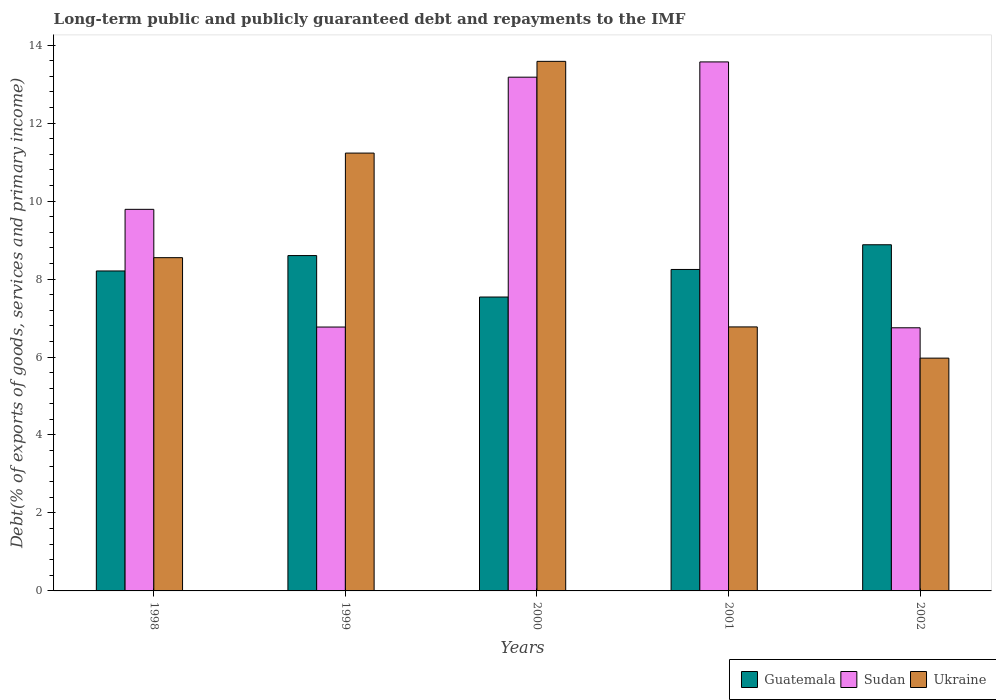Are the number of bars per tick equal to the number of legend labels?
Your answer should be compact. Yes. Are the number of bars on each tick of the X-axis equal?
Keep it short and to the point. Yes. How many bars are there on the 1st tick from the right?
Give a very brief answer. 3. What is the debt and repayments in Ukraine in 1999?
Keep it short and to the point. 11.23. Across all years, what is the maximum debt and repayments in Ukraine?
Your response must be concise. 13.59. Across all years, what is the minimum debt and repayments in Ukraine?
Your response must be concise. 5.97. In which year was the debt and repayments in Guatemala maximum?
Offer a terse response. 2002. What is the total debt and repayments in Guatemala in the graph?
Provide a succinct answer. 41.48. What is the difference between the debt and repayments in Sudan in 1999 and that in 2000?
Keep it short and to the point. -6.41. What is the difference between the debt and repayments in Ukraine in 2000 and the debt and repayments in Sudan in 2001?
Your response must be concise. 0.01. What is the average debt and repayments in Sudan per year?
Your response must be concise. 10.01. In the year 2002, what is the difference between the debt and repayments in Sudan and debt and repayments in Guatemala?
Your answer should be very brief. -2.13. What is the ratio of the debt and repayments in Sudan in 1998 to that in 2002?
Make the answer very short. 1.45. Is the difference between the debt and repayments in Sudan in 1999 and 2002 greater than the difference between the debt and repayments in Guatemala in 1999 and 2002?
Your response must be concise. Yes. What is the difference between the highest and the second highest debt and repayments in Guatemala?
Offer a very short reply. 0.28. What is the difference between the highest and the lowest debt and repayments in Sudan?
Keep it short and to the point. 6.82. Is the sum of the debt and repayments in Guatemala in 1999 and 2002 greater than the maximum debt and repayments in Sudan across all years?
Your answer should be very brief. Yes. What does the 1st bar from the left in 2001 represents?
Your answer should be very brief. Guatemala. What does the 2nd bar from the right in 2000 represents?
Offer a terse response. Sudan. How many bars are there?
Make the answer very short. 15. How many years are there in the graph?
Your answer should be very brief. 5. Does the graph contain any zero values?
Make the answer very short. No. What is the title of the graph?
Ensure brevity in your answer.  Long-term public and publicly guaranteed debt and repayments to the IMF. What is the label or title of the Y-axis?
Ensure brevity in your answer.  Debt(% of exports of goods, services and primary income). What is the Debt(% of exports of goods, services and primary income) in Guatemala in 1998?
Your response must be concise. 8.21. What is the Debt(% of exports of goods, services and primary income) of Sudan in 1998?
Provide a short and direct response. 9.79. What is the Debt(% of exports of goods, services and primary income) in Ukraine in 1998?
Your response must be concise. 8.55. What is the Debt(% of exports of goods, services and primary income) of Guatemala in 1999?
Your response must be concise. 8.6. What is the Debt(% of exports of goods, services and primary income) in Sudan in 1999?
Make the answer very short. 6.77. What is the Debt(% of exports of goods, services and primary income) of Ukraine in 1999?
Make the answer very short. 11.23. What is the Debt(% of exports of goods, services and primary income) of Guatemala in 2000?
Your response must be concise. 7.54. What is the Debt(% of exports of goods, services and primary income) of Sudan in 2000?
Ensure brevity in your answer.  13.18. What is the Debt(% of exports of goods, services and primary income) of Ukraine in 2000?
Give a very brief answer. 13.59. What is the Debt(% of exports of goods, services and primary income) of Guatemala in 2001?
Ensure brevity in your answer.  8.25. What is the Debt(% of exports of goods, services and primary income) of Sudan in 2001?
Provide a succinct answer. 13.57. What is the Debt(% of exports of goods, services and primary income) of Ukraine in 2001?
Your response must be concise. 6.77. What is the Debt(% of exports of goods, services and primary income) in Guatemala in 2002?
Offer a terse response. 8.88. What is the Debt(% of exports of goods, services and primary income) of Sudan in 2002?
Ensure brevity in your answer.  6.75. What is the Debt(% of exports of goods, services and primary income) in Ukraine in 2002?
Your answer should be very brief. 5.97. Across all years, what is the maximum Debt(% of exports of goods, services and primary income) in Guatemala?
Provide a short and direct response. 8.88. Across all years, what is the maximum Debt(% of exports of goods, services and primary income) in Sudan?
Make the answer very short. 13.57. Across all years, what is the maximum Debt(% of exports of goods, services and primary income) in Ukraine?
Give a very brief answer. 13.59. Across all years, what is the minimum Debt(% of exports of goods, services and primary income) in Guatemala?
Offer a very short reply. 7.54. Across all years, what is the minimum Debt(% of exports of goods, services and primary income) in Sudan?
Offer a terse response. 6.75. Across all years, what is the minimum Debt(% of exports of goods, services and primary income) in Ukraine?
Offer a terse response. 5.97. What is the total Debt(% of exports of goods, services and primary income) in Guatemala in the graph?
Your answer should be compact. 41.48. What is the total Debt(% of exports of goods, services and primary income) of Sudan in the graph?
Ensure brevity in your answer.  50.06. What is the total Debt(% of exports of goods, services and primary income) of Ukraine in the graph?
Make the answer very short. 46.11. What is the difference between the Debt(% of exports of goods, services and primary income) in Guatemala in 1998 and that in 1999?
Offer a very short reply. -0.39. What is the difference between the Debt(% of exports of goods, services and primary income) of Sudan in 1998 and that in 1999?
Your answer should be very brief. 3.02. What is the difference between the Debt(% of exports of goods, services and primary income) of Ukraine in 1998 and that in 1999?
Offer a terse response. -2.68. What is the difference between the Debt(% of exports of goods, services and primary income) of Guatemala in 1998 and that in 2000?
Ensure brevity in your answer.  0.67. What is the difference between the Debt(% of exports of goods, services and primary income) in Sudan in 1998 and that in 2000?
Your answer should be very brief. -3.39. What is the difference between the Debt(% of exports of goods, services and primary income) of Ukraine in 1998 and that in 2000?
Ensure brevity in your answer.  -5.04. What is the difference between the Debt(% of exports of goods, services and primary income) of Guatemala in 1998 and that in 2001?
Your answer should be compact. -0.04. What is the difference between the Debt(% of exports of goods, services and primary income) in Sudan in 1998 and that in 2001?
Make the answer very short. -3.78. What is the difference between the Debt(% of exports of goods, services and primary income) in Ukraine in 1998 and that in 2001?
Keep it short and to the point. 1.78. What is the difference between the Debt(% of exports of goods, services and primary income) in Guatemala in 1998 and that in 2002?
Give a very brief answer. -0.67. What is the difference between the Debt(% of exports of goods, services and primary income) of Sudan in 1998 and that in 2002?
Ensure brevity in your answer.  3.04. What is the difference between the Debt(% of exports of goods, services and primary income) in Ukraine in 1998 and that in 2002?
Provide a short and direct response. 2.58. What is the difference between the Debt(% of exports of goods, services and primary income) in Guatemala in 1999 and that in 2000?
Provide a succinct answer. 1.06. What is the difference between the Debt(% of exports of goods, services and primary income) in Sudan in 1999 and that in 2000?
Keep it short and to the point. -6.41. What is the difference between the Debt(% of exports of goods, services and primary income) of Ukraine in 1999 and that in 2000?
Ensure brevity in your answer.  -2.35. What is the difference between the Debt(% of exports of goods, services and primary income) in Guatemala in 1999 and that in 2001?
Your response must be concise. 0.36. What is the difference between the Debt(% of exports of goods, services and primary income) in Sudan in 1999 and that in 2001?
Give a very brief answer. -6.8. What is the difference between the Debt(% of exports of goods, services and primary income) in Ukraine in 1999 and that in 2001?
Your answer should be very brief. 4.46. What is the difference between the Debt(% of exports of goods, services and primary income) of Guatemala in 1999 and that in 2002?
Provide a short and direct response. -0.28. What is the difference between the Debt(% of exports of goods, services and primary income) of Sudan in 1999 and that in 2002?
Offer a terse response. 0.02. What is the difference between the Debt(% of exports of goods, services and primary income) of Ukraine in 1999 and that in 2002?
Provide a short and direct response. 5.26. What is the difference between the Debt(% of exports of goods, services and primary income) in Guatemala in 2000 and that in 2001?
Keep it short and to the point. -0.71. What is the difference between the Debt(% of exports of goods, services and primary income) of Sudan in 2000 and that in 2001?
Make the answer very short. -0.39. What is the difference between the Debt(% of exports of goods, services and primary income) of Ukraine in 2000 and that in 2001?
Your response must be concise. 6.81. What is the difference between the Debt(% of exports of goods, services and primary income) of Guatemala in 2000 and that in 2002?
Provide a succinct answer. -1.34. What is the difference between the Debt(% of exports of goods, services and primary income) in Sudan in 2000 and that in 2002?
Keep it short and to the point. 6.43. What is the difference between the Debt(% of exports of goods, services and primary income) of Ukraine in 2000 and that in 2002?
Ensure brevity in your answer.  7.61. What is the difference between the Debt(% of exports of goods, services and primary income) in Guatemala in 2001 and that in 2002?
Offer a terse response. -0.63. What is the difference between the Debt(% of exports of goods, services and primary income) of Sudan in 2001 and that in 2002?
Provide a succinct answer. 6.82. What is the difference between the Debt(% of exports of goods, services and primary income) in Ukraine in 2001 and that in 2002?
Provide a short and direct response. 0.8. What is the difference between the Debt(% of exports of goods, services and primary income) of Guatemala in 1998 and the Debt(% of exports of goods, services and primary income) of Sudan in 1999?
Your answer should be very brief. 1.44. What is the difference between the Debt(% of exports of goods, services and primary income) of Guatemala in 1998 and the Debt(% of exports of goods, services and primary income) of Ukraine in 1999?
Offer a terse response. -3.02. What is the difference between the Debt(% of exports of goods, services and primary income) of Sudan in 1998 and the Debt(% of exports of goods, services and primary income) of Ukraine in 1999?
Offer a very short reply. -1.44. What is the difference between the Debt(% of exports of goods, services and primary income) of Guatemala in 1998 and the Debt(% of exports of goods, services and primary income) of Sudan in 2000?
Your answer should be very brief. -4.97. What is the difference between the Debt(% of exports of goods, services and primary income) in Guatemala in 1998 and the Debt(% of exports of goods, services and primary income) in Ukraine in 2000?
Your answer should be compact. -5.38. What is the difference between the Debt(% of exports of goods, services and primary income) in Sudan in 1998 and the Debt(% of exports of goods, services and primary income) in Ukraine in 2000?
Offer a terse response. -3.8. What is the difference between the Debt(% of exports of goods, services and primary income) in Guatemala in 1998 and the Debt(% of exports of goods, services and primary income) in Sudan in 2001?
Offer a terse response. -5.36. What is the difference between the Debt(% of exports of goods, services and primary income) of Guatemala in 1998 and the Debt(% of exports of goods, services and primary income) of Ukraine in 2001?
Give a very brief answer. 1.44. What is the difference between the Debt(% of exports of goods, services and primary income) in Sudan in 1998 and the Debt(% of exports of goods, services and primary income) in Ukraine in 2001?
Give a very brief answer. 3.02. What is the difference between the Debt(% of exports of goods, services and primary income) in Guatemala in 1998 and the Debt(% of exports of goods, services and primary income) in Sudan in 2002?
Provide a succinct answer. 1.46. What is the difference between the Debt(% of exports of goods, services and primary income) in Guatemala in 1998 and the Debt(% of exports of goods, services and primary income) in Ukraine in 2002?
Your answer should be very brief. 2.24. What is the difference between the Debt(% of exports of goods, services and primary income) of Sudan in 1998 and the Debt(% of exports of goods, services and primary income) of Ukraine in 2002?
Provide a short and direct response. 3.82. What is the difference between the Debt(% of exports of goods, services and primary income) in Guatemala in 1999 and the Debt(% of exports of goods, services and primary income) in Sudan in 2000?
Offer a terse response. -4.58. What is the difference between the Debt(% of exports of goods, services and primary income) in Guatemala in 1999 and the Debt(% of exports of goods, services and primary income) in Ukraine in 2000?
Make the answer very short. -4.98. What is the difference between the Debt(% of exports of goods, services and primary income) of Sudan in 1999 and the Debt(% of exports of goods, services and primary income) of Ukraine in 2000?
Provide a succinct answer. -6.82. What is the difference between the Debt(% of exports of goods, services and primary income) of Guatemala in 1999 and the Debt(% of exports of goods, services and primary income) of Sudan in 2001?
Your answer should be very brief. -4.97. What is the difference between the Debt(% of exports of goods, services and primary income) in Guatemala in 1999 and the Debt(% of exports of goods, services and primary income) in Ukraine in 2001?
Your response must be concise. 1.83. What is the difference between the Debt(% of exports of goods, services and primary income) of Sudan in 1999 and the Debt(% of exports of goods, services and primary income) of Ukraine in 2001?
Your answer should be very brief. -0. What is the difference between the Debt(% of exports of goods, services and primary income) in Guatemala in 1999 and the Debt(% of exports of goods, services and primary income) in Sudan in 2002?
Ensure brevity in your answer.  1.85. What is the difference between the Debt(% of exports of goods, services and primary income) in Guatemala in 1999 and the Debt(% of exports of goods, services and primary income) in Ukraine in 2002?
Keep it short and to the point. 2.63. What is the difference between the Debt(% of exports of goods, services and primary income) in Sudan in 1999 and the Debt(% of exports of goods, services and primary income) in Ukraine in 2002?
Provide a succinct answer. 0.8. What is the difference between the Debt(% of exports of goods, services and primary income) in Guatemala in 2000 and the Debt(% of exports of goods, services and primary income) in Sudan in 2001?
Offer a very short reply. -6.03. What is the difference between the Debt(% of exports of goods, services and primary income) in Guatemala in 2000 and the Debt(% of exports of goods, services and primary income) in Ukraine in 2001?
Offer a terse response. 0.77. What is the difference between the Debt(% of exports of goods, services and primary income) in Sudan in 2000 and the Debt(% of exports of goods, services and primary income) in Ukraine in 2001?
Your answer should be very brief. 6.41. What is the difference between the Debt(% of exports of goods, services and primary income) of Guatemala in 2000 and the Debt(% of exports of goods, services and primary income) of Sudan in 2002?
Give a very brief answer. 0.79. What is the difference between the Debt(% of exports of goods, services and primary income) in Guatemala in 2000 and the Debt(% of exports of goods, services and primary income) in Ukraine in 2002?
Give a very brief answer. 1.57. What is the difference between the Debt(% of exports of goods, services and primary income) of Sudan in 2000 and the Debt(% of exports of goods, services and primary income) of Ukraine in 2002?
Give a very brief answer. 7.21. What is the difference between the Debt(% of exports of goods, services and primary income) of Guatemala in 2001 and the Debt(% of exports of goods, services and primary income) of Sudan in 2002?
Your answer should be compact. 1.5. What is the difference between the Debt(% of exports of goods, services and primary income) of Guatemala in 2001 and the Debt(% of exports of goods, services and primary income) of Ukraine in 2002?
Give a very brief answer. 2.27. What is the difference between the Debt(% of exports of goods, services and primary income) in Sudan in 2001 and the Debt(% of exports of goods, services and primary income) in Ukraine in 2002?
Your answer should be compact. 7.6. What is the average Debt(% of exports of goods, services and primary income) in Guatemala per year?
Keep it short and to the point. 8.3. What is the average Debt(% of exports of goods, services and primary income) of Sudan per year?
Your response must be concise. 10.01. What is the average Debt(% of exports of goods, services and primary income) of Ukraine per year?
Your answer should be compact. 9.22. In the year 1998, what is the difference between the Debt(% of exports of goods, services and primary income) of Guatemala and Debt(% of exports of goods, services and primary income) of Sudan?
Provide a succinct answer. -1.58. In the year 1998, what is the difference between the Debt(% of exports of goods, services and primary income) of Guatemala and Debt(% of exports of goods, services and primary income) of Ukraine?
Your answer should be compact. -0.34. In the year 1998, what is the difference between the Debt(% of exports of goods, services and primary income) of Sudan and Debt(% of exports of goods, services and primary income) of Ukraine?
Provide a short and direct response. 1.24. In the year 1999, what is the difference between the Debt(% of exports of goods, services and primary income) in Guatemala and Debt(% of exports of goods, services and primary income) in Sudan?
Offer a terse response. 1.83. In the year 1999, what is the difference between the Debt(% of exports of goods, services and primary income) of Guatemala and Debt(% of exports of goods, services and primary income) of Ukraine?
Give a very brief answer. -2.63. In the year 1999, what is the difference between the Debt(% of exports of goods, services and primary income) of Sudan and Debt(% of exports of goods, services and primary income) of Ukraine?
Make the answer very short. -4.46. In the year 2000, what is the difference between the Debt(% of exports of goods, services and primary income) of Guatemala and Debt(% of exports of goods, services and primary income) of Sudan?
Ensure brevity in your answer.  -5.64. In the year 2000, what is the difference between the Debt(% of exports of goods, services and primary income) of Guatemala and Debt(% of exports of goods, services and primary income) of Ukraine?
Ensure brevity in your answer.  -6.05. In the year 2000, what is the difference between the Debt(% of exports of goods, services and primary income) in Sudan and Debt(% of exports of goods, services and primary income) in Ukraine?
Your answer should be compact. -0.41. In the year 2001, what is the difference between the Debt(% of exports of goods, services and primary income) of Guatemala and Debt(% of exports of goods, services and primary income) of Sudan?
Your answer should be compact. -5.32. In the year 2001, what is the difference between the Debt(% of exports of goods, services and primary income) of Guatemala and Debt(% of exports of goods, services and primary income) of Ukraine?
Provide a short and direct response. 1.47. In the year 2001, what is the difference between the Debt(% of exports of goods, services and primary income) in Sudan and Debt(% of exports of goods, services and primary income) in Ukraine?
Make the answer very short. 6.8. In the year 2002, what is the difference between the Debt(% of exports of goods, services and primary income) in Guatemala and Debt(% of exports of goods, services and primary income) in Sudan?
Provide a succinct answer. 2.13. In the year 2002, what is the difference between the Debt(% of exports of goods, services and primary income) in Guatemala and Debt(% of exports of goods, services and primary income) in Ukraine?
Offer a terse response. 2.91. In the year 2002, what is the difference between the Debt(% of exports of goods, services and primary income) in Sudan and Debt(% of exports of goods, services and primary income) in Ukraine?
Your answer should be compact. 0.78. What is the ratio of the Debt(% of exports of goods, services and primary income) in Guatemala in 1998 to that in 1999?
Ensure brevity in your answer.  0.95. What is the ratio of the Debt(% of exports of goods, services and primary income) of Sudan in 1998 to that in 1999?
Give a very brief answer. 1.45. What is the ratio of the Debt(% of exports of goods, services and primary income) of Ukraine in 1998 to that in 1999?
Make the answer very short. 0.76. What is the ratio of the Debt(% of exports of goods, services and primary income) in Guatemala in 1998 to that in 2000?
Your response must be concise. 1.09. What is the ratio of the Debt(% of exports of goods, services and primary income) in Sudan in 1998 to that in 2000?
Keep it short and to the point. 0.74. What is the ratio of the Debt(% of exports of goods, services and primary income) in Ukraine in 1998 to that in 2000?
Make the answer very short. 0.63. What is the ratio of the Debt(% of exports of goods, services and primary income) in Guatemala in 1998 to that in 2001?
Make the answer very short. 1. What is the ratio of the Debt(% of exports of goods, services and primary income) of Sudan in 1998 to that in 2001?
Keep it short and to the point. 0.72. What is the ratio of the Debt(% of exports of goods, services and primary income) in Ukraine in 1998 to that in 2001?
Ensure brevity in your answer.  1.26. What is the ratio of the Debt(% of exports of goods, services and primary income) of Guatemala in 1998 to that in 2002?
Provide a succinct answer. 0.92. What is the ratio of the Debt(% of exports of goods, services and primary income) of Sudan in 1998 to that in 2002?
Provide a succinct answer. 1.45. What is the ratio of the Debt(% of exports of goods, services and primary income) in Ukraine in 1998 to that in 2002?
Provide a succinct answer. 1.43. What is the ratio of the Debt(% of exports of goods, services and primary income) of Guatemala in 1999 to that in 2000?
Your answer should be compact. 1.14. What is the ratio of the Debt(% of exports of goods, services and primary income) of Sudan in 1999 to that in 2000?
Give a very brief answer. 0.51. What is the ratio of the Debt(% of exports of goods, services and primary income) of Ukraine in 1999 to that in 2000?
Give a very brief answer. 0.83. What is the ratio of the Debt(% of exports of goods, services and primary income) in Guatemala in 1999 to that in 2001?
Your answer should be very brief. 1.04. What is the ratio of the Debt(% of exports of goods, services and primary income) in Sudan in 1999 to that in 2001?
Your answer should be compact. 0.5. What is the ratio of the Debt(% of exports of goods, services and primary income) in Ukraine in 1999 to that in 2001?
Offer a terse response. 1.66. What is the ratio of the Debt(% of exports of goods, services and primary income) in Guatemala in 1999 to that in 2002?
Your answer should be compact. 0.97. What is the ratio of the Debt(% of exports of goods, services and primary income) in Sudan in 1999 to that in 2002?
Your answer should be very brief. 1. What is the ratio of the Debt(% of exports of goods, services and primary income) of Ukraine in 1999 to that in 2002?
Offer a terse response. 1.88. What is the ratio of the Debt(% of exports of goods, services and primary income) of Guatemala in 2000 to that in 2001?
Make the answer very short. 0.91. What is the ratio of the Debt(% of exports of goods, services and primary income) of Sudan in 2000 to that in 2001?
Ensure brevity in your answer.  0.97. What is the ratio of the Debt(% of exports of goods, services and primary income) in Ukraine in 2000 to that in 2001?
Your answer should be very brief. 2.01. What is the ratio of the Debt(% of exports of goods, services and primary income) in Guatemala in 2000 to that in 2002?
Keep it short and to the point. 0.85. What is the ratio of the Debt(% of exports of goods, services and primary income) of Sudan in 2000 to that in 2002?
Offer a terse response. 1.95. What is the ratio of the Debt(% of exports of goods, services and primary income) in Ukraine in 2000 to that in 2002?
Your answer should be compact. 2.27. What is the ratio of the Debt(% of exports of goods, services and primary income) in Guatemala in 2001 to that in 2002?
Offer a terse response. 0.93. What is the ratio of the Debt(% of exports of goods, services and primary income) of Sudan in 2001 to that in 2002?
Give a very brief answer. 2.01. What is the ratio of the Debt(% of exports of goods, services and primary income) in Ukraine in 2001 to that in 2002?
Keep it short and to the point. 1.13. What is the difference between the highest and the second highest Debt(% of exports of goods, services and primary income) in Guatemala?
Make the answer very short. 0.28. What is the difference between the highest and the second highest Debt(% of exports of goods, services and primary income) of Sudan?
Your answer should be very brief. 0.39. What is the difference between the highest and the second highest Debt(% of exports of goods, services and primary income) of Ukraine?
Give a very brief answer. 2.35. What is the difference between the highest and the lowest Debt(% of exports of goods, services and primary income) of Guatemala?
Provide a succinct answer. 1.34. What is the difference between the highest and the lowest Debt(% of exports of goods, services and primary income) of Sudan?
Keep it short and to the point. 6.82. What is the difference between the highest and the lowest Debt(% of exports of goods, services and primary income) of Ukraine?
Make the answer very short. 7.61. 